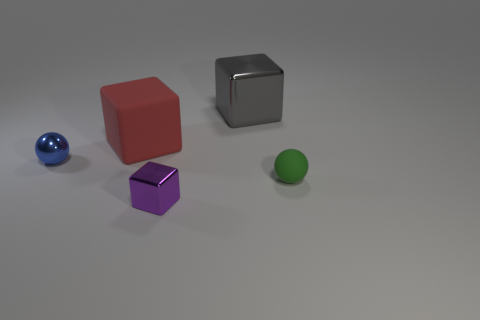There is a small ball in front of the small blue thing; are there any things behind it?
Ensure brevity in your answer.  Yes. How many other things are there of the same material as the big red block?
Ensure brevity in your answer.  1. Does the tiny metallic object left of the big matte object have the same shape as the thing that is to the right of the gray cube?
Keep it short and to the point. Yes. Is the red block made of the same material as the small green ball?
Offer a terse response. Yes. There is a metal block behind the ball left of the metallic block that is on the right side of the purple metal object; what is its size?
Offer a very short reply. Large. What number of other things are there of the same color as the small cube?
Give a very brief answer. 0. The blue thing that is the same size as the purple object is what shape?
Provide a succinct answer. Sphere. How many tiny things are either green balls or blue shiny spheres?
Offer a very short reply. 2. There is a tiny ball that is to the right of the tiny sphere behind the tiny rubber ball; are there any large objects behind it?
Give a very brief answer. Yes. Are there any other shiny cubes that have the same size as the red cube?
Your response must be concise. Yes. 